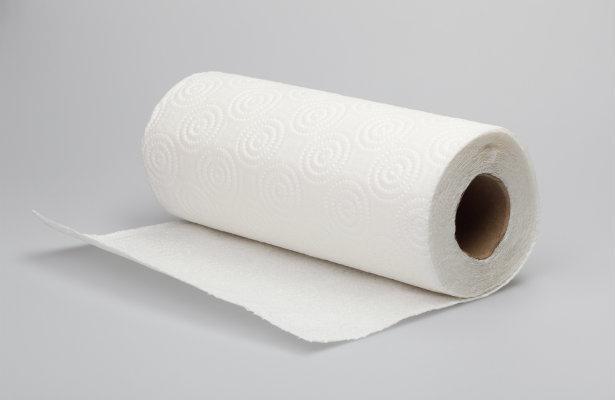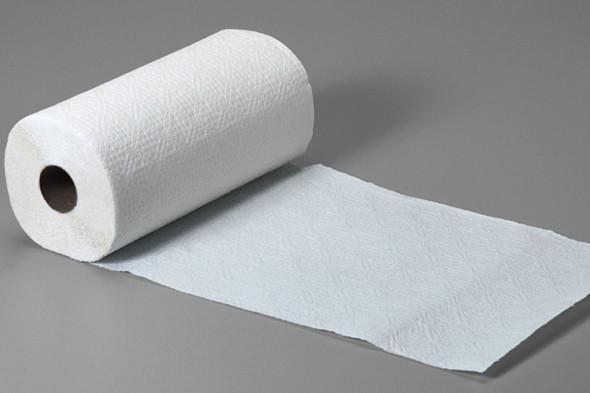The first image is the image on the left, the second image is the image on the right. Given the left and right images, does the statement "there is exactly one standing roll of paper towels in the image on the left" hold true? Answer yes or no. No. The first image is the image on the left, the second image is the image on the right. Evaluate the accuracy of this statement regarding the images: "There is a brown roll of paper towels in the image on the right.". Is it true? Answer yes or no. No. 